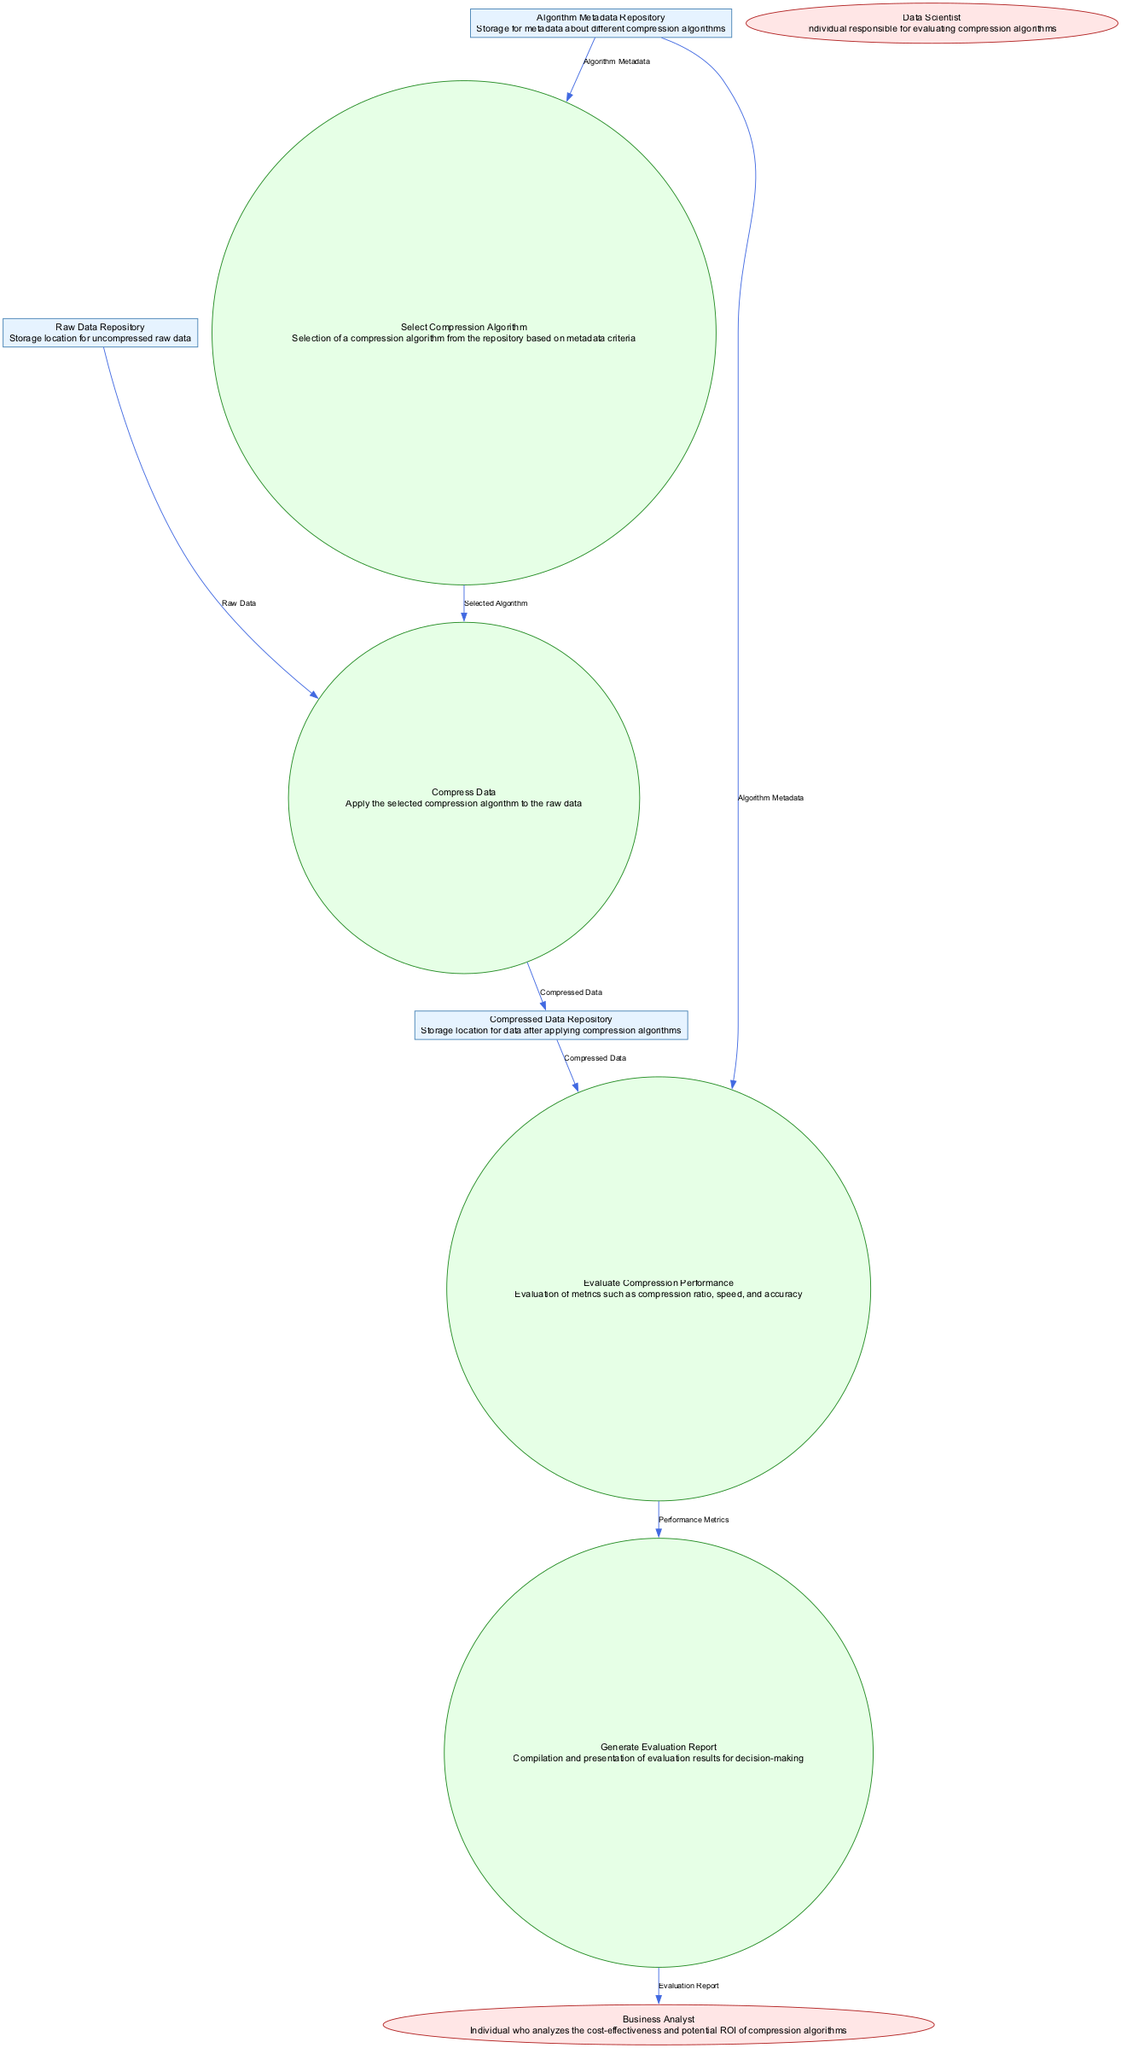What is the name of the data store that contains uncompressed raw data? The diagram shows a data store labeled "Raw Data Repository," which is used to store uncompressed raw data according to its description.
Answer: Raw Data Repository How many external entities are present in the diagram? By examining the diagram, it is noted that there are two external entities: "Data Scientist" and "Business Analyst." Therefore, the total count is two.
Answer: 2 What process follows the "Select Compression Algorithm" process? The diagram indicates the flow direction from the "Select Compression Algorithm" process (P1) to the "Compress Data" process (P2), making P2 the next process.
Answer: Compress Data Which process evaluates the performance metrics? According to the diagram, the "Evaluate Compression Performance" process (P3) is responsible for evaluating the performance metrics, as indicated by the input data flows leading into this process.
Answer: Evaluate Compression Performance What type of data flows from the Compressed Data Repository to the Evaluate Compression Performance process? The data flowing from the "Compressed Data Repository" (DS2) to the "Evaluate Compression Performance" process (P3) is labeled "Compressed Data." This indicates the specific type of data being transferred.
Answer: Compressed Data Who receives the Evaluation Report generated in the process? The diagram depicts that the "Generate Evaluation Report" (P4) process outputs to the "Business Analyst" (EE2), making the Business Analyst the recipient of the report.
Answer: Business Analyst What are the two inputs for the "Evaluate Compression Performance" process? The diagram specifies that the "Evaluate Compression Performance" process (P3) has inputs originating from two sources: the "Compressed Data Repository" (DS2) and the "Algorithm Metadata Repository" (DS3).
Answer: Compressed Data, Algorithm Metadata Which external entity is responsible for evaluating compression algorithms? The diagram labels the external entity "Data Scientist" as the individual who is responsible for evaluating compression algorithms, based on its description.
Answer: Data Scientist How many data flows are outgoing from the process "Generate Evaluation Report"? By examining the diagram, it is clear that the "Generate Evaluation Report" process (P4) has only one outgoing data flow leading to the external entity "Business Analyst."
Answer: 1 